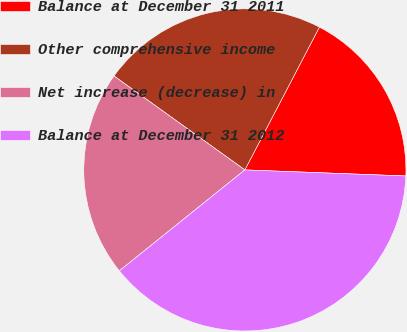Convert chart. <chart><loc_0><loc_0><loc_500><loc_500><pie_chart><fcel>Balance at December 31 2011<fcel>Other comprehensive income<fcel>Net increase (decrease) in<fcel>Balance at December 31 2012<nl><fcel>17.94%<fcel>22.75%<fcel>20.69%<fcel>38.62%<nl></chart> 